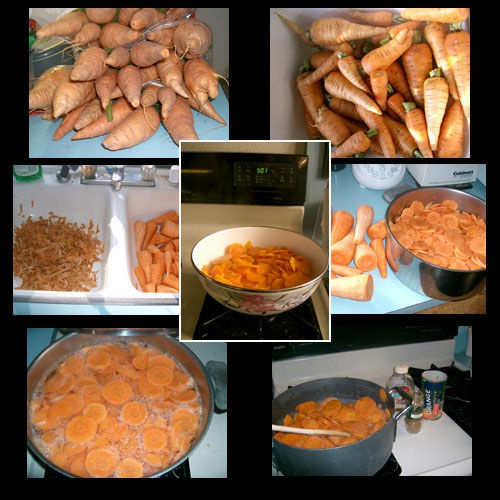Describe the objects in this image and their specific colors. I can see oven in black, olive, and tan tones, bowl in black, orange, red, and gray tones, dining table in black, orange, lightblue, and darkgray tones, carrot in black, red, and orange tones, and bowl in black, purple, and red tones in this image. 